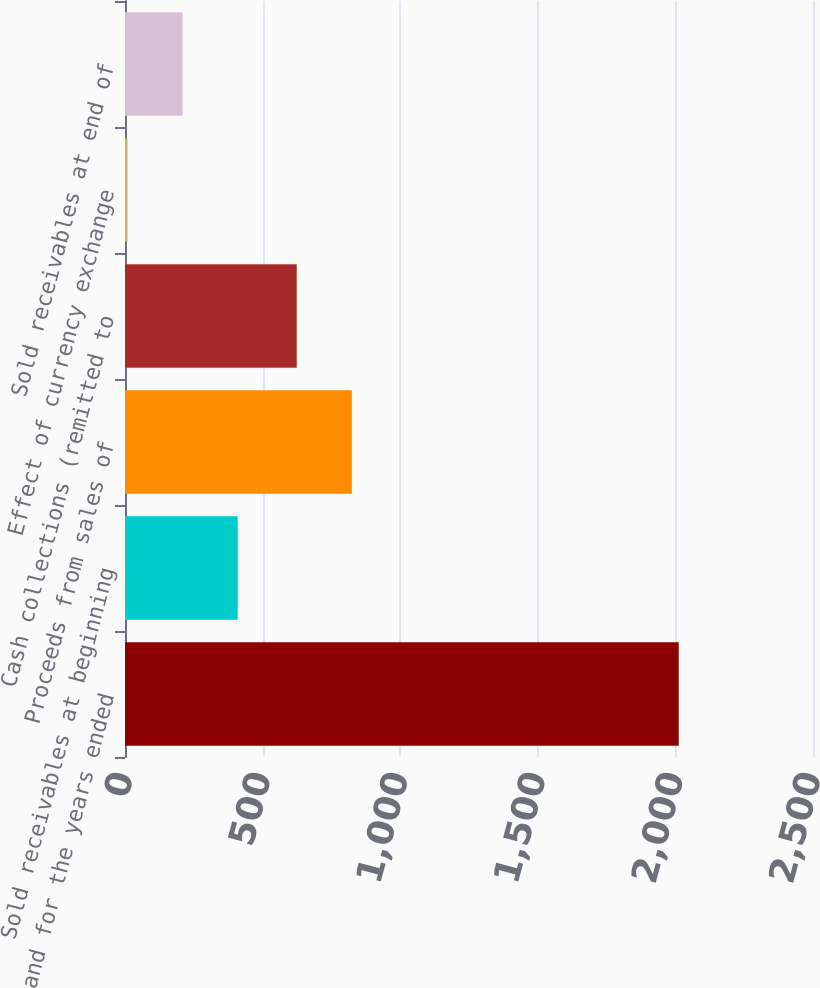Convert chart to OTSL. <chart><loc_0><loc_0><loc_500><loc_500><bar_chart><fcel>as of and for the years ended<fcel>Sold receivables at beginning<fcel>Proceeds from sales of<fcel>Cash collections (remitted to<fcel>Effect of currency exchange<fcel>Sold receivables at end of<nl><fcel>2012<fcel>409.6<fcel>824.3<fcel>624<fcel>9<fcel>209.3<nl></chart> 